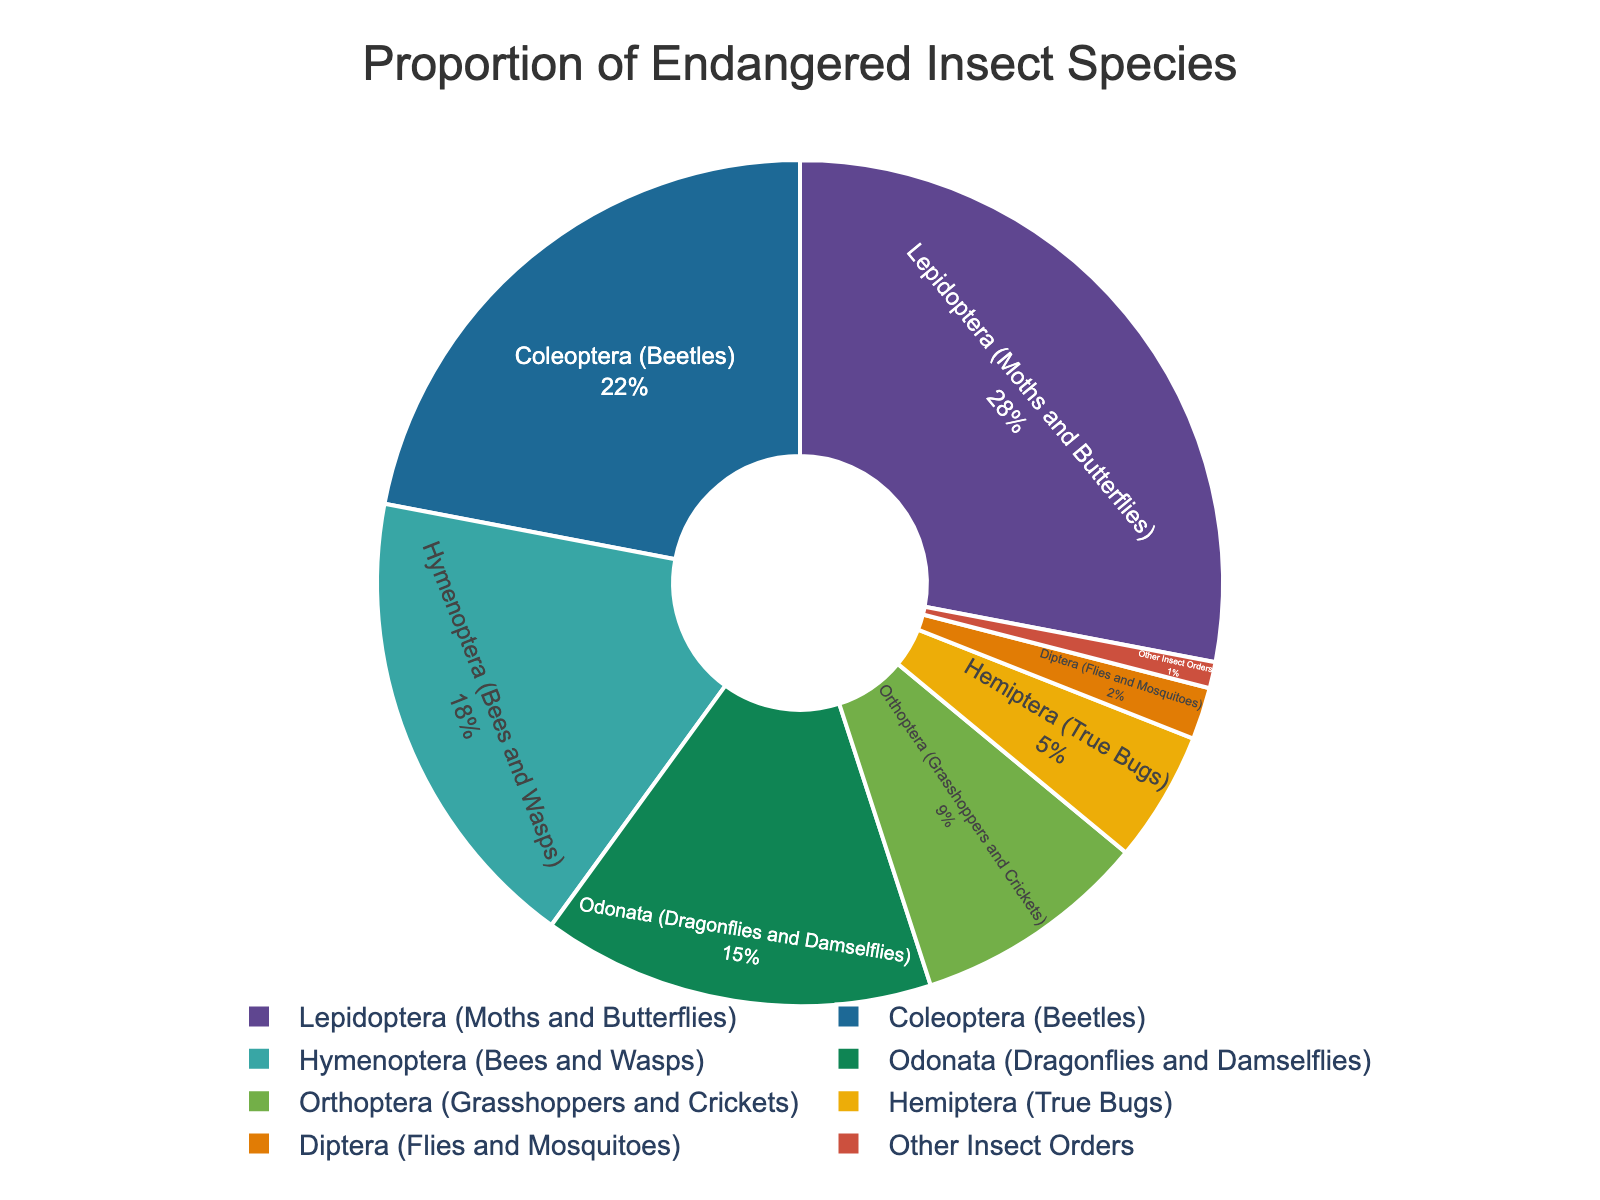Which insect group has the largest proportion of endangered species? The largest portion of the pie chart represents Lepidoptera (Moths and Butterflies).
Answer: Lepidoptera Which insect group has the smallest proportion of endangered species? The smallest portion of the pie chart represents Other Insect Orders.
Answer: Other Insect Orders What is the combined proportion of endangered species for Lepidoptera and Coleoptera? The proportion for Lepidoptera is 0.28 and for Coleoptera is 0.22. Adding them gives 0.28 + 0.22 = 0.50
Answer: 0.50 Which two insect groups have a combined endangered species proportion equal to that of Lepidoptera? The combined proportions of Hymenoptera (0.18) and Orthoptera (0.09) equal 0.27, which is closest but not exactly 0.28. A direct equality does not exist with other groupings in the provided data.
Answer: None Which insect groups combined account for exactly half of the endangered species in this ecosystem? Lepidoptera is 0.28 and Coleoptera is 0.22, their sum is 0.50, which totals half of the endangered species.
Answer: Lepidoptera and Coleoptera How does the proportion of endangered Hymenoptera compare to that of Odonata? The proportion of Hymenoptera (0.18) is higher than that of Odonata (0.15).
Answer: Hymenoptera is higher Which color represents the Diptera group in the pie chart? The colors are distributed sequentially from a predefined palette, and the legend helps identify the Diptera group.
Answer: Determined by the legend/color scheme (this requires a visual reference) By how much does the proportion of endangered Lepidoptera species exceed that of Orthoptera species? The proportion for Lepidoptera is 0.28 and for Orthoptera is 0.09. Subtracting these gives 0.28 - 0.09 = 0.19
Answer: 0.19 Which three insect groups account for over two-thirds of the endangered species? Lepidoptera (0.28), Coleoptera (0.22), and Hymenoptera (0.18) combined give 0.28 + 0.22 + 0.18 = 0.68, which is over two-thirds.
Answer: Lepidoptera, Coleoptera, and Hymenoptera What is the proportion difference between Hemiptera and Diptera? The proportion for Hemiptera is 0.05 and for Diptera is 0.02. Subtracting these gives 0.05 - 0.02 = 0.03
Answer: 0.03 